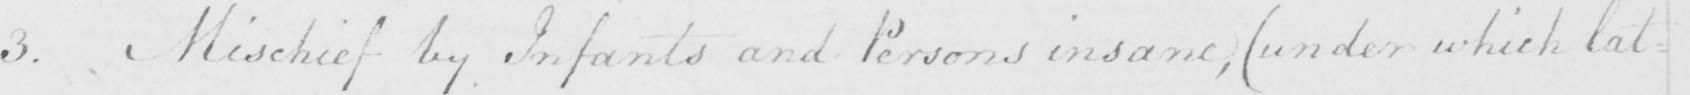Can you tell me what this handwritten text says? 3 . Mischief by Infants and Persons insane ,  ( under which lat= 